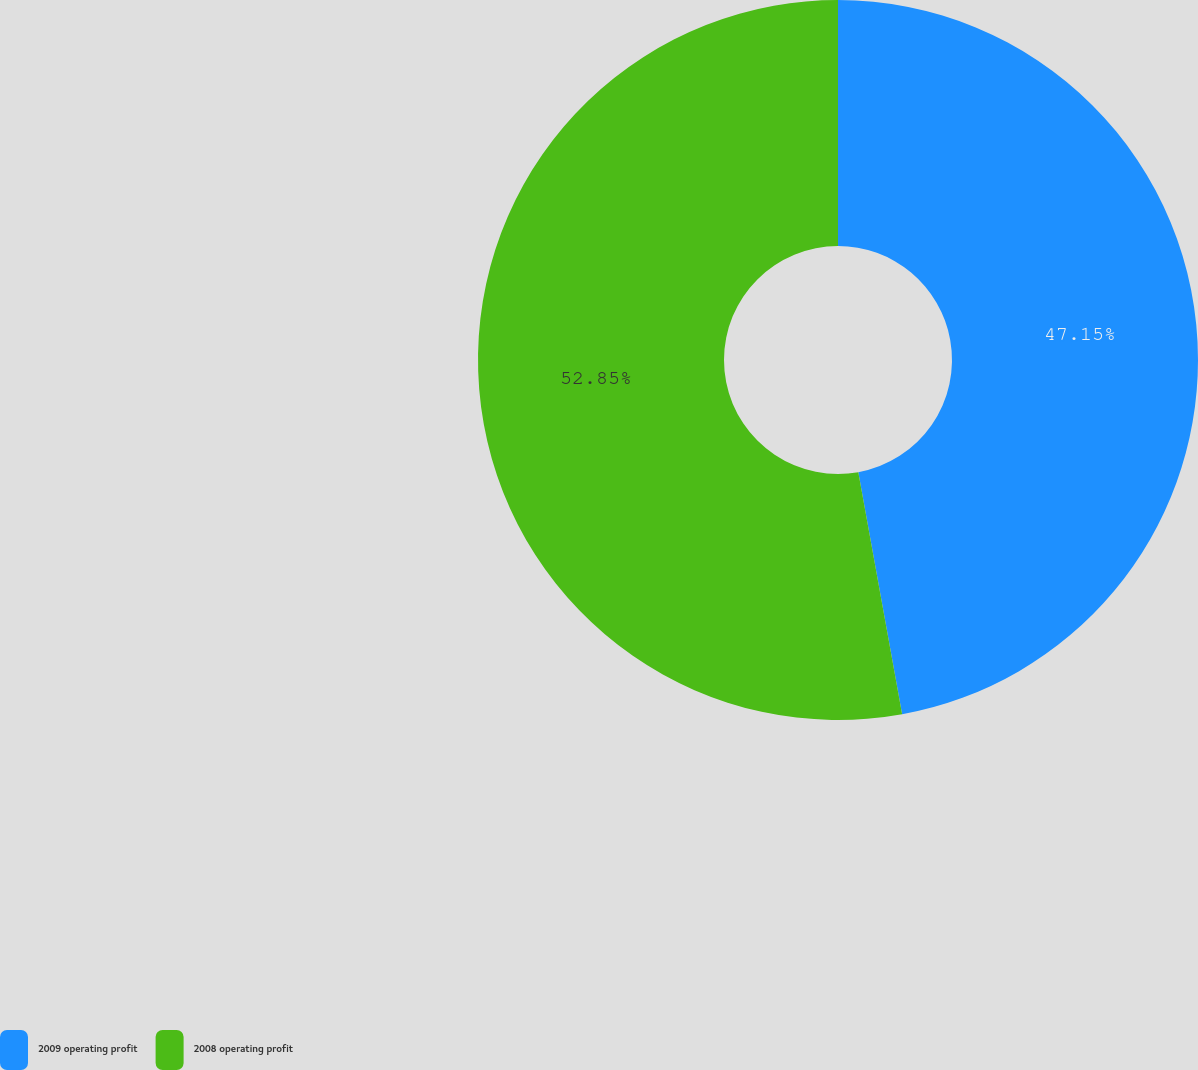Convert chart. <chart><loc_0><loc_0><loc_500><loc_500><pie_chart><fcel>2009 operating profit<fcel>2008 operating profit<nl><fcel>47.15%<fcel>52.85%<nl></chart> 